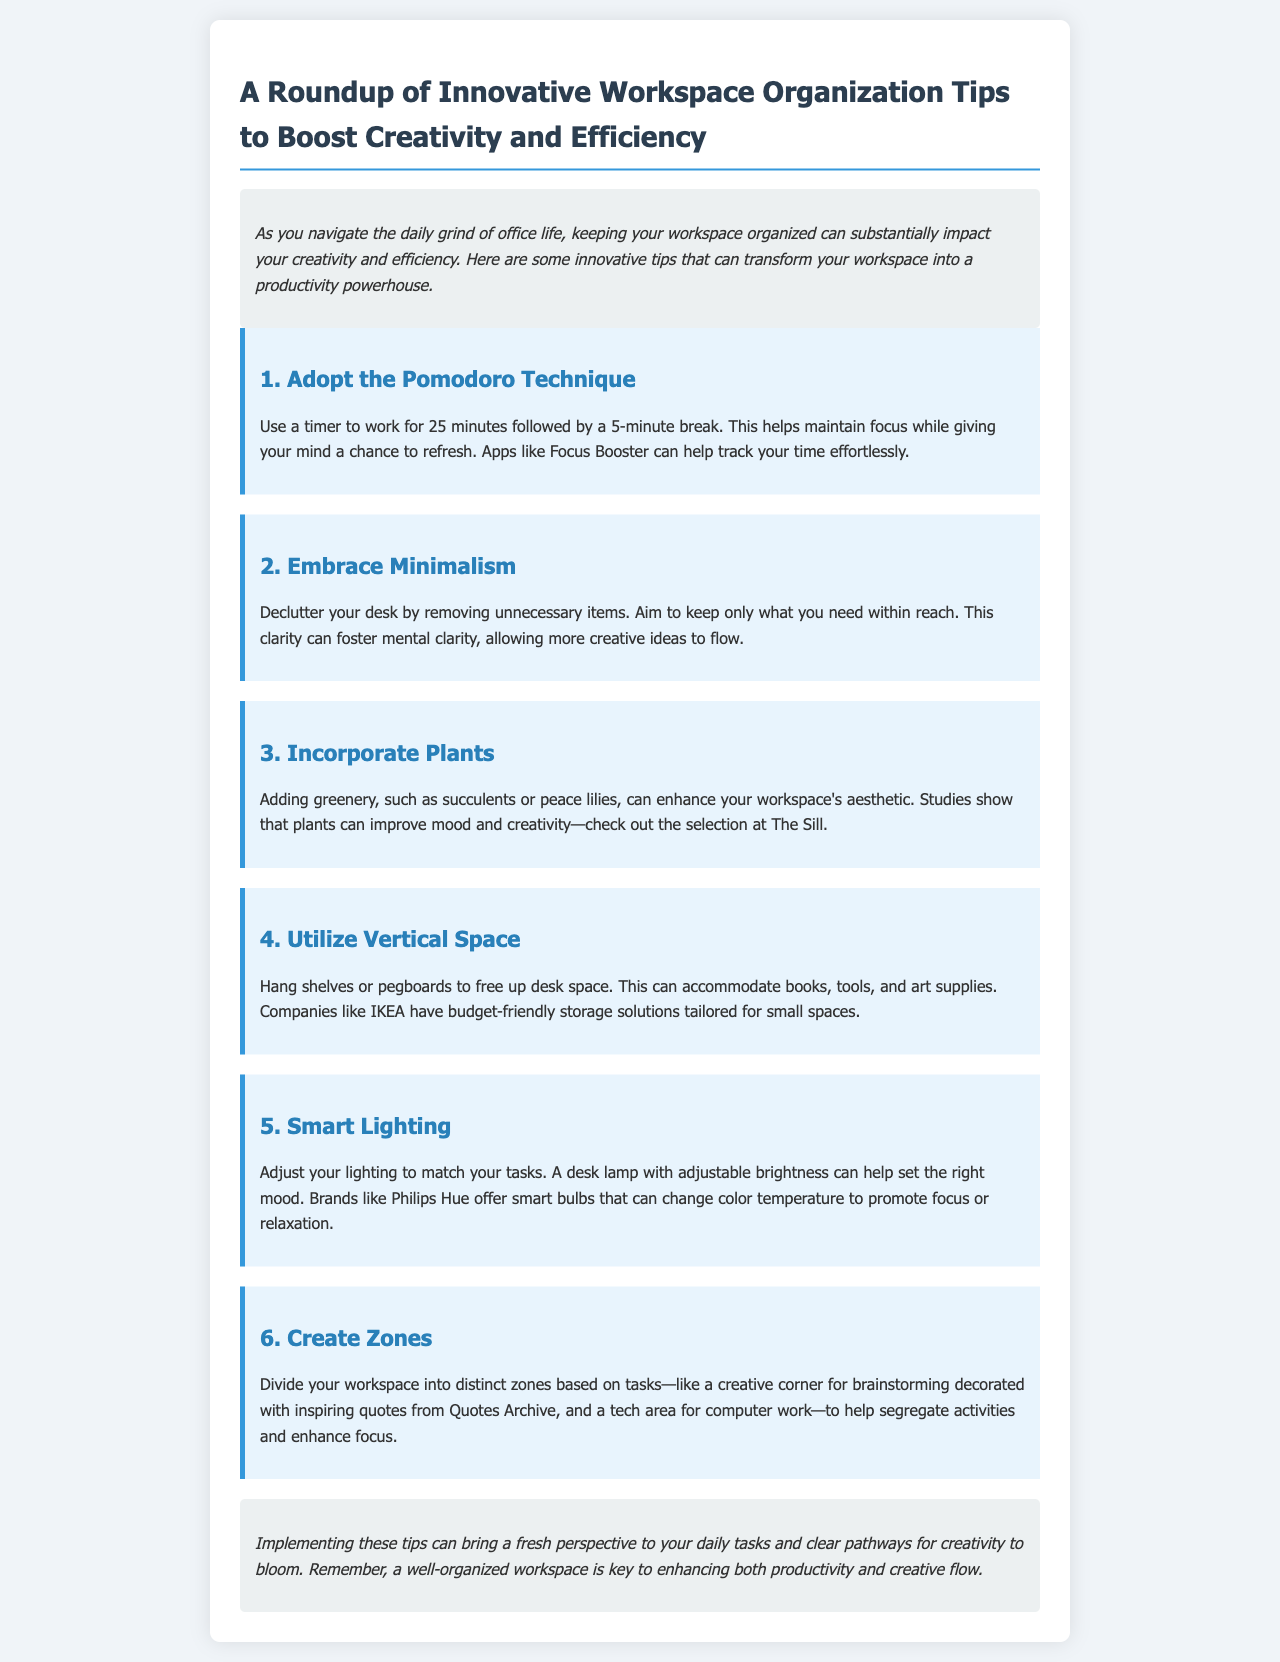what is the title of the newsletter? The title of the newsletter is provided in the header section, summarizing the content about workspace organization tips.
Answer: A Roundup of Innovative Workspace Organization Tips to Boost Creativity and Efficiency how many workspace organization tips are mentioned? The document lists a total of six tips for workspace organization in the tips section.
Answer: 6 what technique is suggested to maintain focus while working? The Pomodoro Technique is outlined as a method to enhance focus by using timed work sessions followed by short breaks.
Answer: Pomodoro Technique which item is recommended to improve mood and creativity? Incorporating plants, such as succulents or peace lilies, is suggested to enhance the workspace's mood and creativity.
Answer: Plants what should you create to enhance focus in your workspace? The document recommends creating zones in your workspace for different tasks to segregate activities.
Answer: Zones which brand offers smart bulbs that can change color temperature? Philips Hue is mentioned as a brand that provides smart bulbs for adjusting lighting to different tasks.
Answer: Philips Hue 